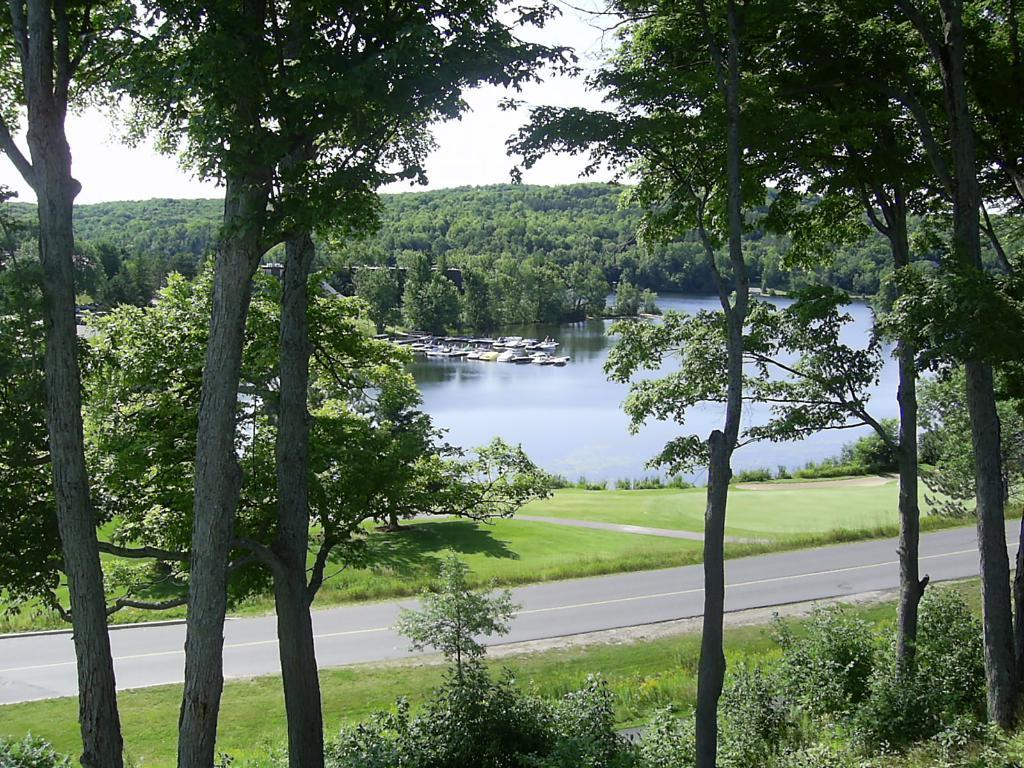What is the main feature of the image? There is a road in the image. What can be seen on both sides of the road? There are many trees on both sides of the road. What is visible in the background of the image? There are boats and additional trees in the background of the image. What else can be seen in the background of the image? The sky is visible in the background of the image. How many turkeys are sitting on the button in the image? There are no turkeys or buttons present in the image. 